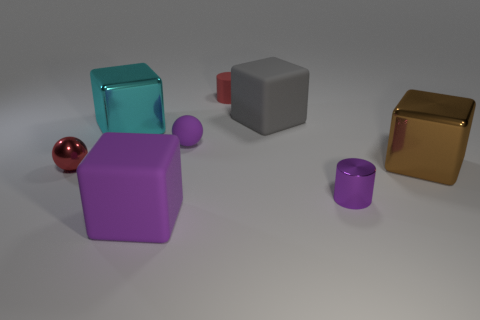Subtract 1 cubes. How many cubes are left? 3 Add 1 large brown blocks. How many objects exist? 9 Subtract all cylinders. How many objects are left? 6 Add 6 metal blocks. How many metal blocks exist? 8 Subtract 1 brown blocks. How many objects are left? 7 Subtract all big gray rubber blocks. Subtract all big cyan metal objects. How many objects are left? 6 Add 7 purple matte balls. How many purple matte balls are left? 8 